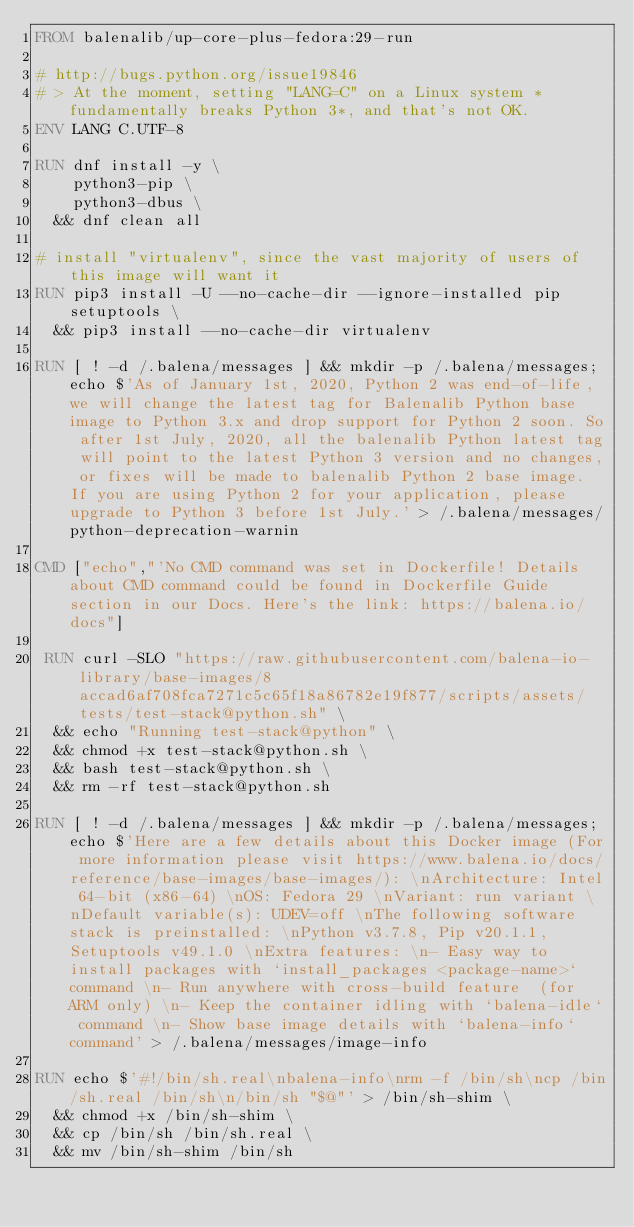<code> <loc_0><loc_0><loc_500><loc_500><_Dockerfile_>FROM balenalib/up-core-plus-fedora:29-run

# http://bugs.python.org/issue19846
# > At the moment, setting "LANG=C" on a Linux system *fundamentally breaks Python 3*, and that's not OK.
ENV LANG C.UTF-8

RUN dnf install -y \
		python3-pip \
		python3-dbus \
	&& dnf clean all

# install "virtualenv", since the vast majority of users of this image will want it
RUN pip3 install -U --no-cache-dir --ignore-installed pip setuptools \
	&& pip3 install --no-cache-dir virtualenv

RUN [ ! -d /.balena/messages ] && mkdir -p /.balena/messages; echo $'As of January 1st, 2020, Python 2 was end-of-life, we will change the latest tag for Balenalib Python base image to Python 3.x and drop support for Python 2 soon. So after 1st July, 2020, all the balenalib Python latest tag will point to the latest Python 3 version and no changes, or fixes will be made to balenalib Python 2 base image. If you are using Python 2 for your application, please upgrade to Python 3 before 1st July.' > /.balena/messages/python-deprecation-warnin

CMD ["echo","'No CMD command was set in Dockerfile! Details about CMD command could be found in Dockerfile Guide section in our Docs. Here's the link: https://balena.io/docs"]

 RUN curl -SLO "https://raw.githubusercontent.com/balena-io-library/base-images/8accad6af708fca7271c5c65f18a86782e19f877/scripts/assets/tests/test-stack@python.sh" \
  && echo "Running test-stack@python" \
  && chmod +x test-stack@python.sh \
  && bash test-stack@python.sh \
  && rm -rf test-stack@python.sh 

RUN [ ! -d /.balena/messages ] && mkdir -p /.balena/messages; echo $'Here are a few details about this Docker image (For more information please visit https://www.balena.io/docs/reference/base-images/base-images/): \nArchitecture: Intel 64-bit (x86-64) \nOS: Fedora 29 \nVariant: run variant \nDefault variable(s): UDEV=off \nThe following software stack is preinstalled: \nPython v3.7.8, Pip v20.1.1, Setuptools v49.1.0 \nExtra features: \n- Easy way to install packages with `install_packages <package-name>` command \n- Run anywhere with cross-build feature  (for ARM only) \n- Keep the container idling with `balena-idle` command \n- Show base image details with `balena-info` command' > /.balena/messages/image-info

RUN echo $'#!/bin/sh.real\nbalena-info\nrm -f /bin/sh\ncp /bin/sh.real /bin/sh\n/bin/sh "$@"' > /bin/sh-shim \
	&& chmod +x /bin/sh-shim \
	&& cp /bin/sh /bin/sh.real \
	&& mv /bin/sh-shim /bin/sh</code> 